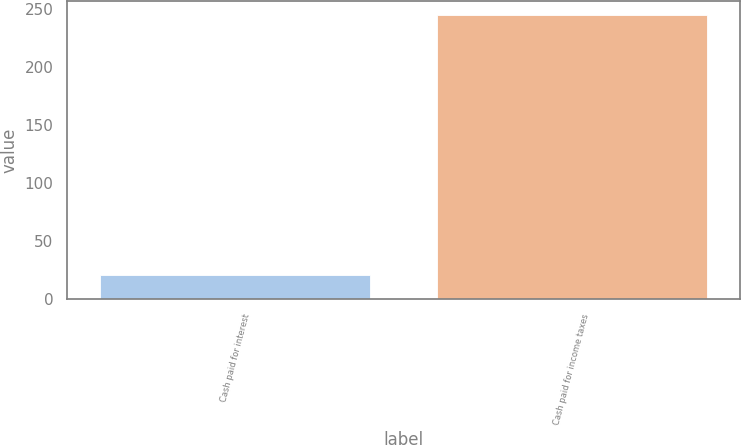Convert chart to OTSL. <chart><loc_0><loc_0><loc_500><loc_500><bar_chart><fcel>Cash paid for interest<fcel>Cash paid for income taxes<nl><fcel>20.9<fcel>244.6<nl></chart> 